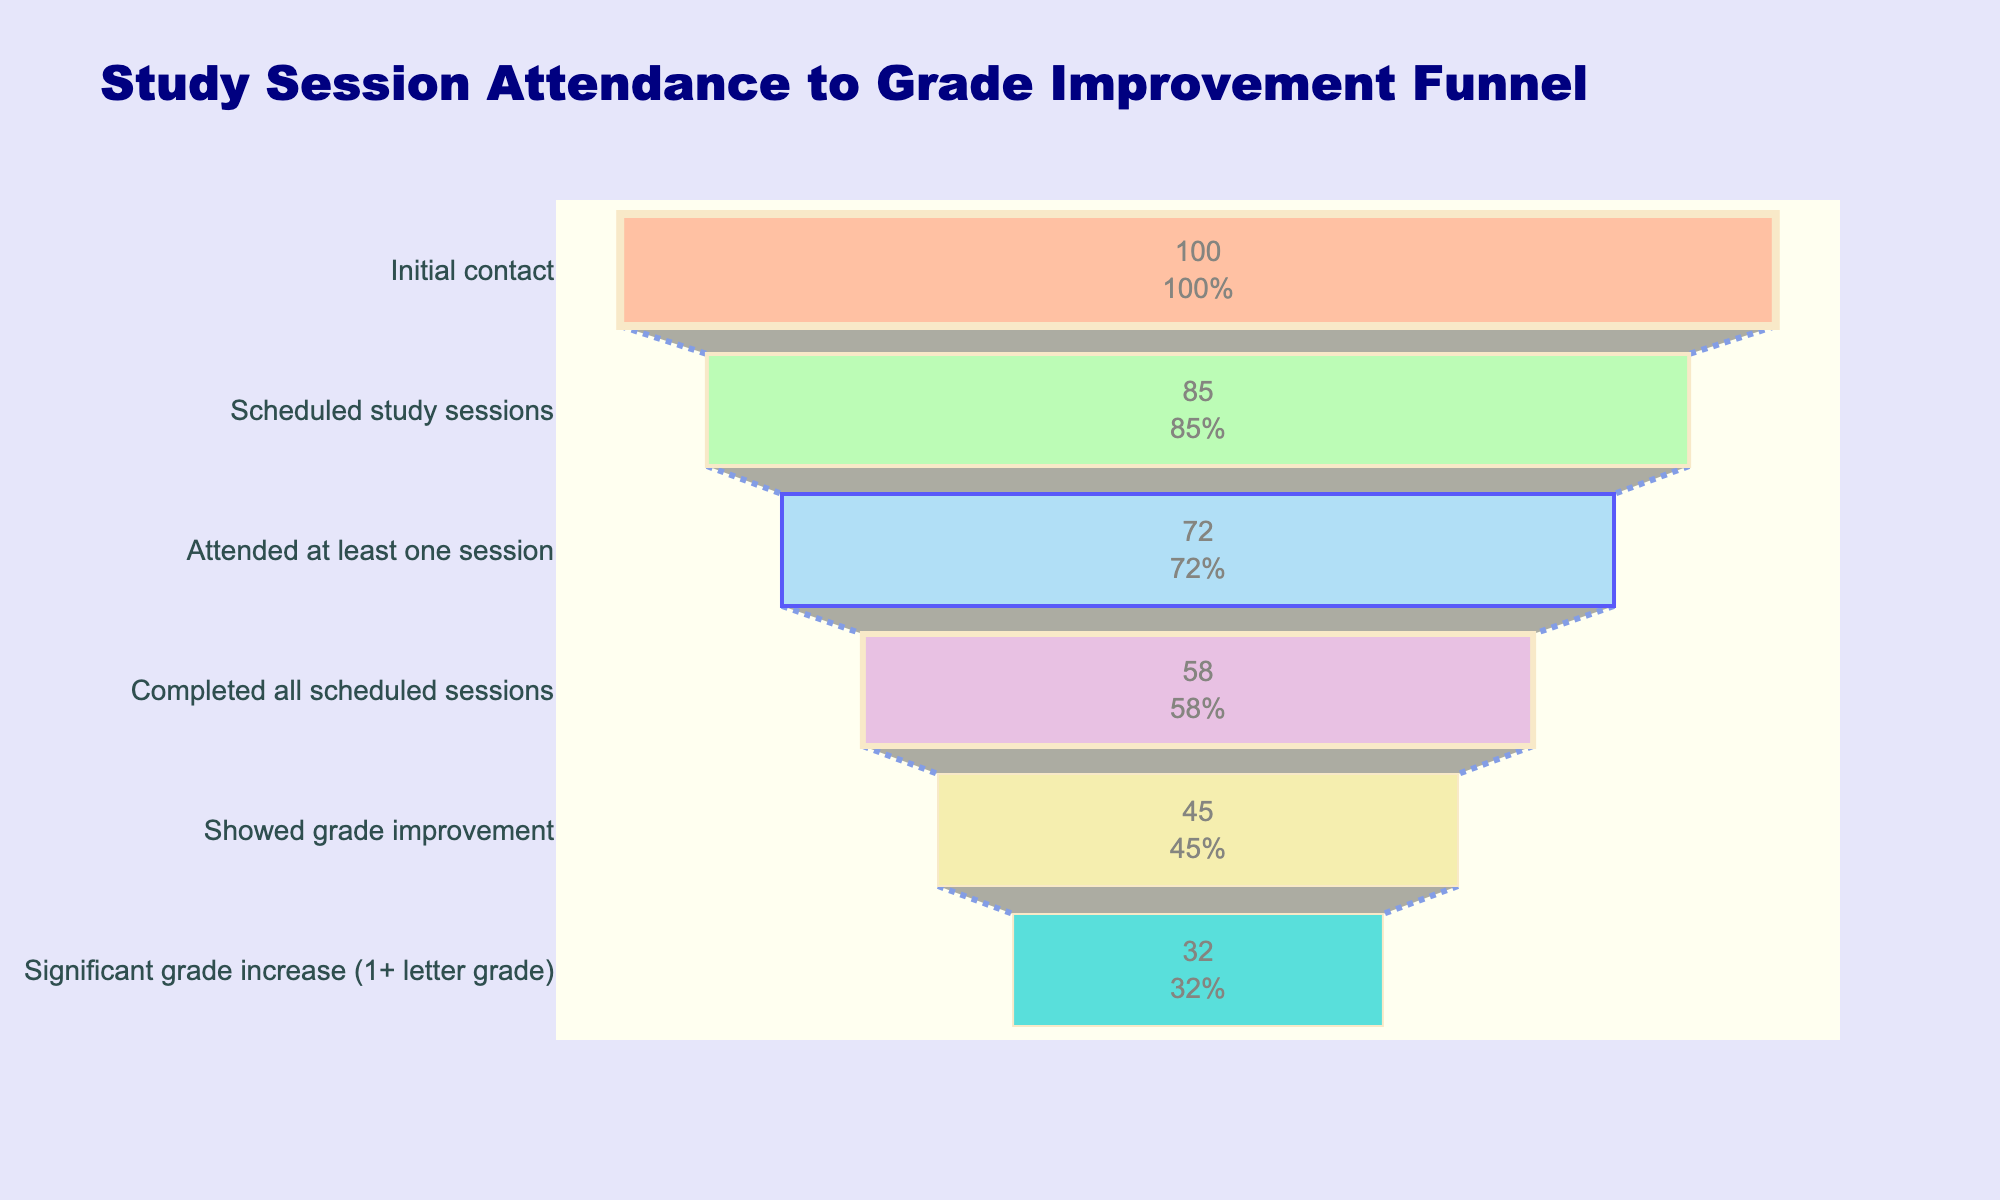What is the title of the chart? The title is displayed at the top of the chart and reads "Study Session Attendance to Grade Improvement Funnel."
Answer: Study Session Attendance to Grade Improvement Funnel How many stages are there in the funnel chart? The stages are listed along the vertical axis, and we can count them to find the total number.
Answer: Six What percentage of students showed grade improvement? The percentage of students who showed grade improvement is displayed beside the "Showed grade improvement" stage.
Answer: 45% How many students completed all scheduled sessions? The number of students who completed all scheduled sessions is shown inside the corresponding funnel segment.
Answer: 58 What is the initial number of students contacted? The number of students initially contacted is provided in the first stage of the funnel.
Answer: 100 What is the difference between students who attended at least one session and those who showed a significant grade increase? We subtract the number of students who showed a significant grade increase from those who attended at least one session.
Answer: 72 - 32 = 40 How does the percentage of students attending at least one session compare to those who completed all scheduled sessions? Compare the percentages shown by the segments for attended at least one session (72%) and completed all scheduled sessions (58%).
Answer: Attended at least one session is greater than completed all scheduled sessions What color represents the stage "Scheduled study sessions"? Identify the color specific to the "Scheduled study sessions" segment in the funnel chart.
Answer: Green Which stage has the smallest number of students, and how many are they? Compare the student counts for all stages to find the smallest one.
Answer: Significant grade increase, 32 What percentage of students progressed from attending at least one session to completing all scheduled sessions? Calculate the percentage by dividing the number of students who completed all sessions by those who attended at least one, then multiply by 100.
Answer: (58 / 72) * 100 ≈ 80.6% 